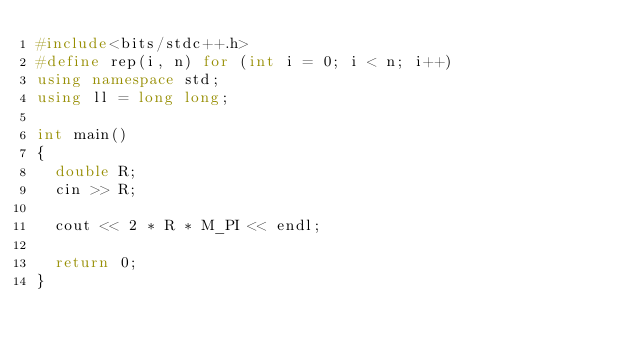Convert code to text. <code><loc_0><loc_0><loc_500><loc_500><_C++_>#include<bits/stdc++.h>
#define rep(i, n) for (int i = 0; i < n; i++)
using namespace std;
using ll = long long;
 
int main()
{
  double R;
  cin >> R;
  
  cout << 2 * R * M_PI << endl;
 
  return 0;
}</code> 